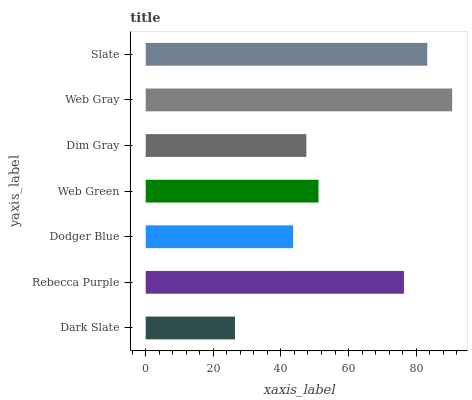Is Dark Slate the minimum?
Answer yes or no. Yes. Is Web Gray the maximum?
Answer yes or no. Yes. Is Rebecca Purple the minimum?
Answer yes or no. No. Is Rebecca Purple the maximum?
Answer yes or no. No. Is Rebecca Purple greater than Dark Slate?
Answer yes or no. Yes. Is Dark Slate less than Rebecca Purple?
Answer yes or no. Yes. Is Dark Slate greater than Rebecca Purple?
Answer yes or no. No. Is Rebecca Purple less than Dark Slate?
Answer yes or no. No. Is Web Green the high median?
Answer yes or no. Yes. Is Web Green the low median?
Answer yes or no. Yes. Is Rebecca Purple the high median?
Answer yes or no. No. Is Rebecca Purple the low median?
Answer yes or no. No. 